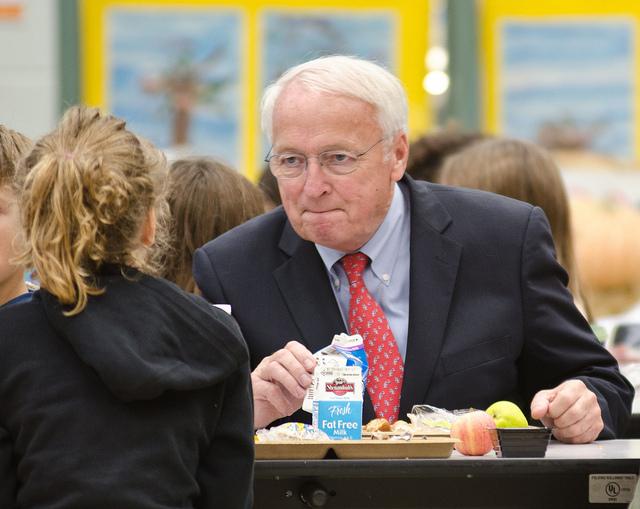Are the people out on a lunch?
Write a very short answer. Yes. What type of milk is on the tray?
Short answer required. Fat free. What color is his tie?
Concise answer only. Red. 